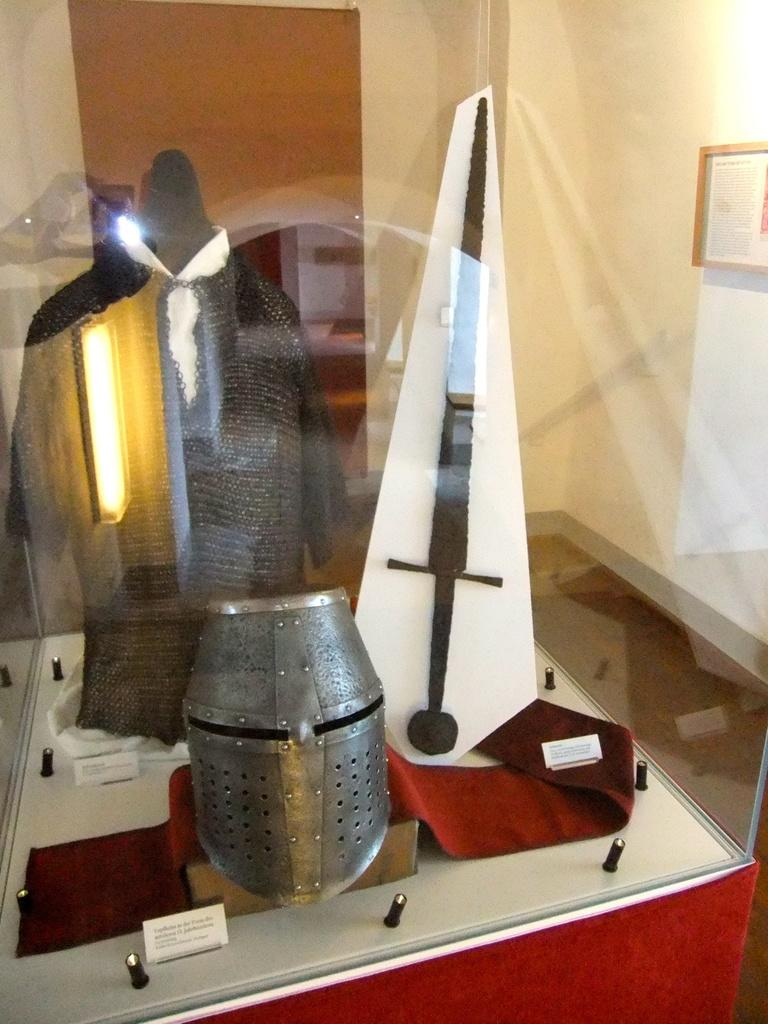What is contained within the glass box in the image? There are artifacts with labels in a closed glass box. What can be seen behind the glass box? There is a door behind the glass box. What is hanging on the wall in the image? There is a photo frame on the wall. Can you tell me how many tigers are visible in the photo frame on the wall? There are no tigers visible in the photo frame on the wall; it contains a different image or artwork. Is there a boy standing next to the glass box in the image? There is no boy present in the image. 